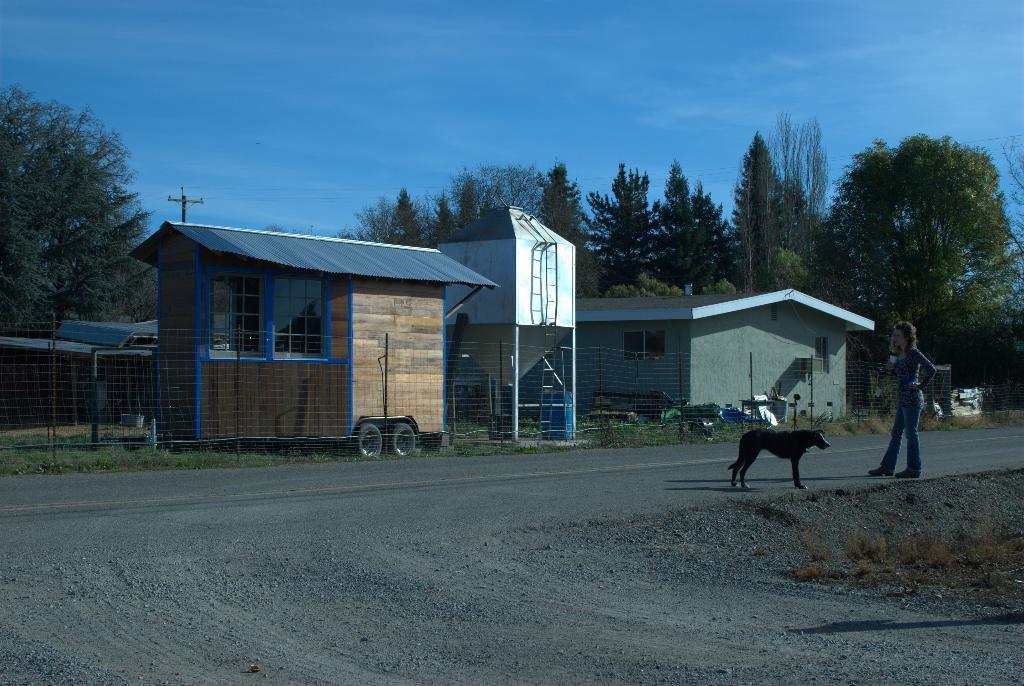Could you give a brief overview of what you see in this image? In this image I can see few buildings,windows,tank,net fencing,poles and few trees. I can see a person and dog on the road. The sky is in blue color. 